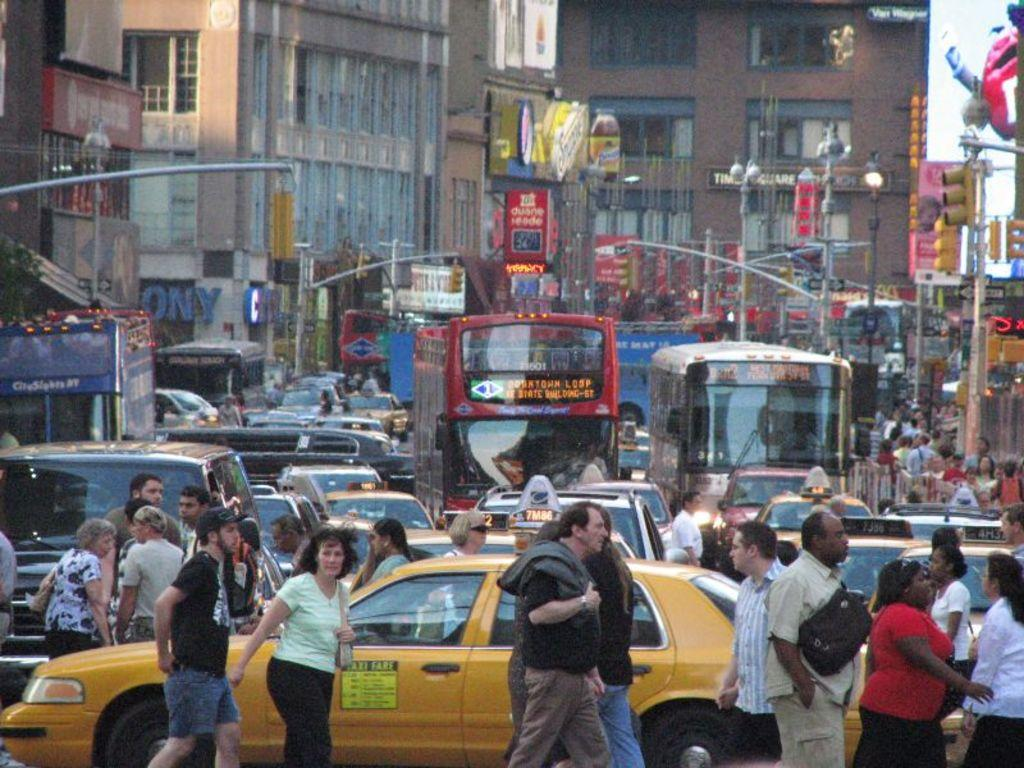<image>
Give a short and clear explanation of the subsequent image. A sign on the side of a taxi says "Taxi Fare" at the top and then lists prices. 